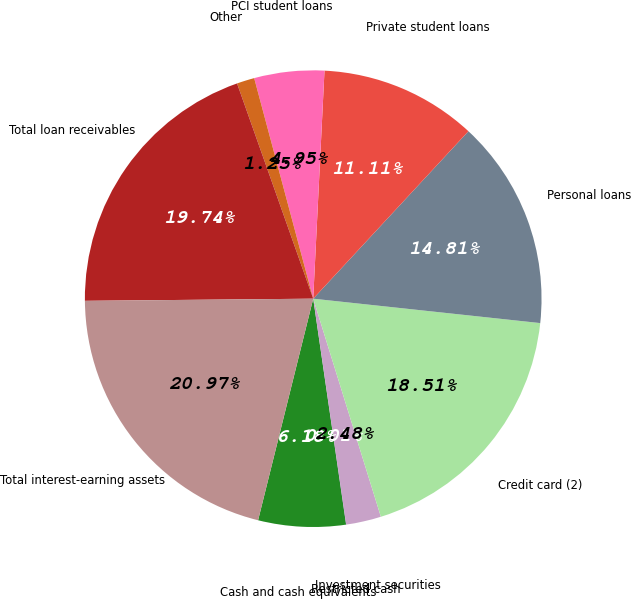Convert chart. <chart><loc_0><loc_0><loc_500><loc_500><pie_chart><fcel>Cash and cash equivalents<fcel>Restricted cash<fcel>Investment securities<fcel>Credit card (2)<fcel>Personal loans<fcel>Private student loans<fcel>PCI student loans<fcel>Other<fcel>Total loan receivables<fcel>Total interest-earning assets<nl><fcel>6.18%<fcel>0.01%<fcel>2.48%<fcel>18.51%<fcel>14.81%<fcel>11.11%<fcel>4.95%<fcel>1.25%<fcel>19.74%<fcel>20.97%<nl></chart> 